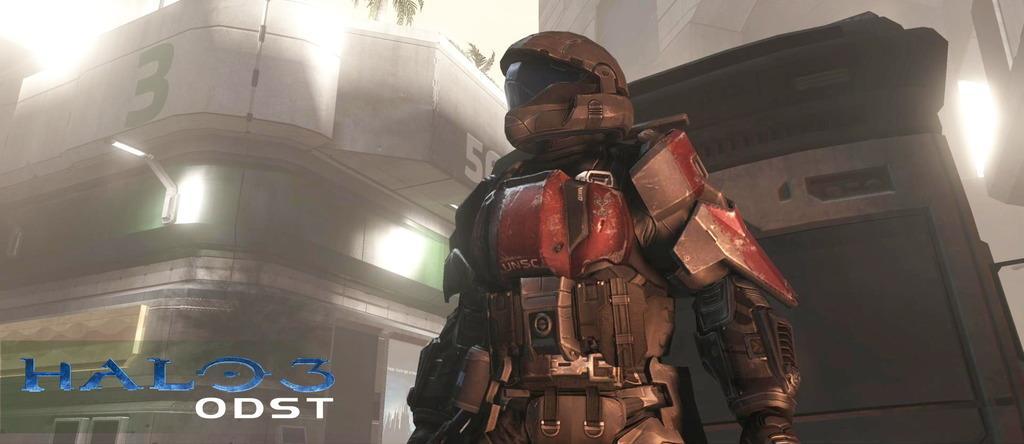Please provide a concise description of this image. There is a person with a costume. In the background there are buildings with lights. In the left bottom corner there is something written. 